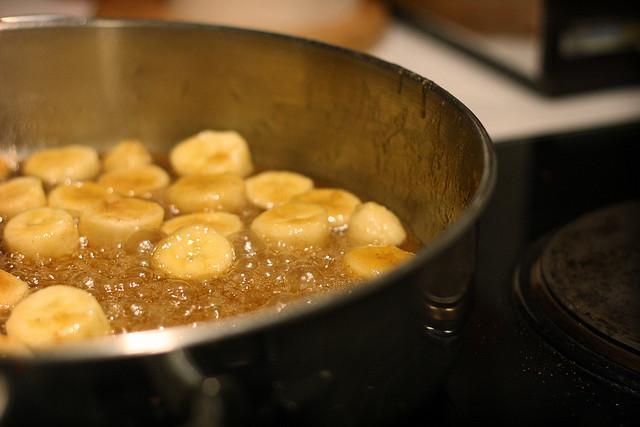How many bananas are there?
Give a very brief answer. 8. How many people are wearing hats?
Give a very brief answer. 0. 